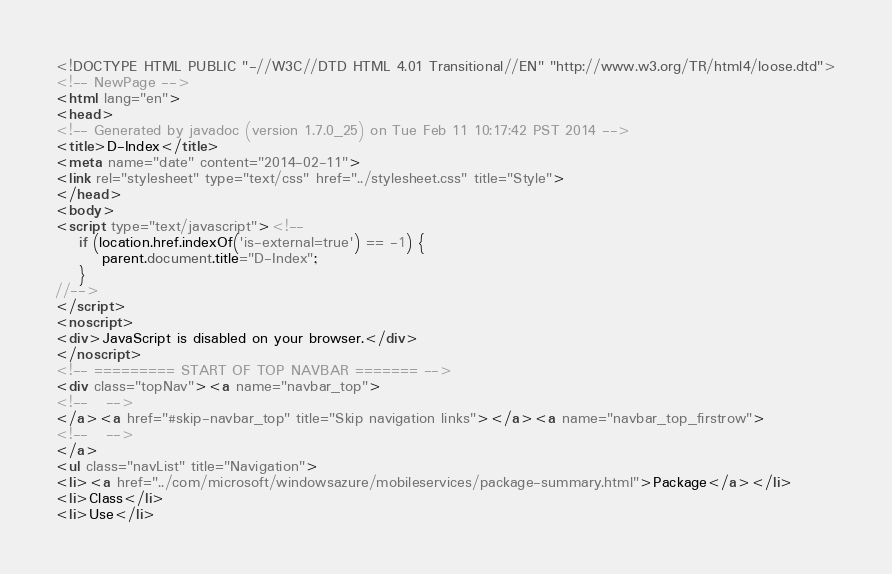Convert code to text. <code><loc_0><loc_0><loc_500><loc_500><_HTML_><!DOCTYPE HTML PUBLIC "-//W3C//DTD HTML 4.01 Transitional//EN" "http://www.w3.org/TR/html4/loose.dtd">
<!-- NewPage -->
<html lang="en">
<head>
<!-- Generated by javadoc (version 1.7.0_25) on Tue Feb 11 10:17:42 PST 2014 -->
<title>D-Index</title>
<meta name="date" content="2014-02-11">
<link rel="stylesheet" type="text/css" href="../stylesheet.css" title="Style">
</head>
<body>
<script type="text/javascript"><!--
    if (location.href.indexOf('is-external=true') == -1) {
        parent.document.title="D-Index";
    }
//-->
</script>
<noscript>
<div>JavaScript is disabled on your browser.</div>
</noscript>
<!-- ========= START OF TOP NAVBAR ======= -->
<div class="topNav"><a name="navbar_top">
<!--   -->
</a><a href="#skip-navbar_top" title="Skip navigation links"></a><a name="navbar_top_firstrow">
<!--   -->
</a>
<ul class="navList" title="Navigation">
<li><a href="../com/microsoft/windowsazure/mobileservices/package-summary.html">Package</a></li>
<li>Class</li>
<li>Use</li></code> 